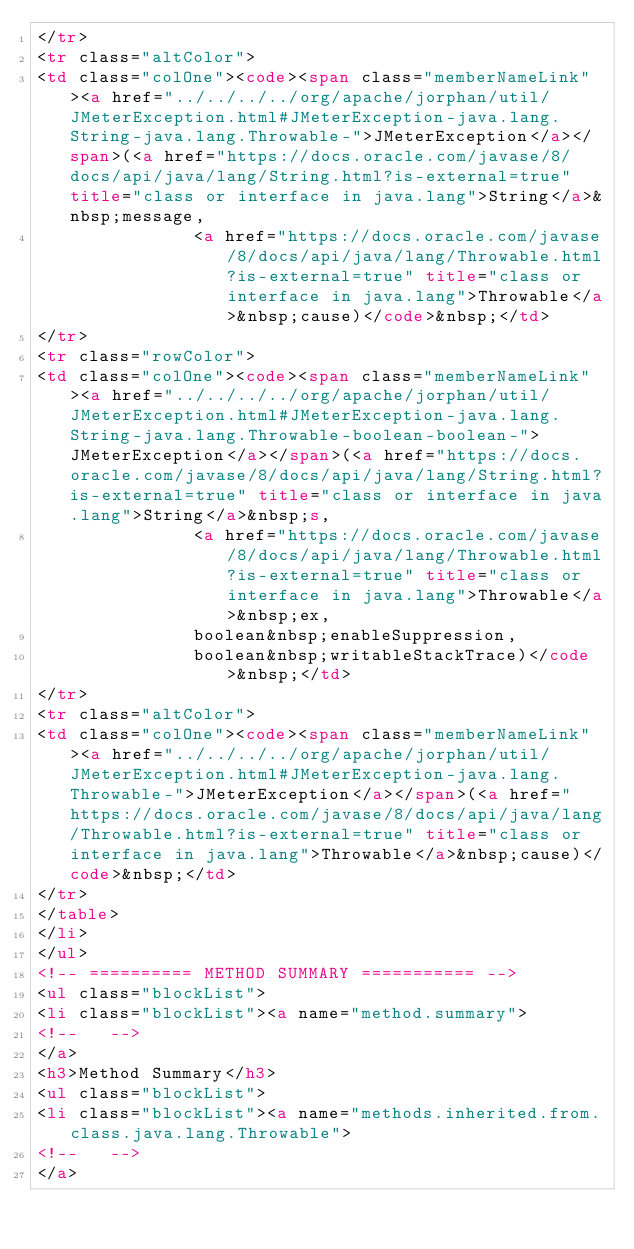Convert code to text. <code><loc_0><loc_0><loc_500><loc_500><_HTML_></tr>
<tr class="altColor">
<td class="colOne"><code><span class="memberNameLink"><a href="../../../../org/apache/jorphan/util/JMeterException.html#JMeterException-java.lang.String-java.lang.Throwable-">JMeterException</a></span>(<a href="https://docs.oracle.com/javase/8/docs/api/java/lang/String.html?is-external=true" title="class or interface in java.lang">String</a>&nbsp;message,
               <a href="https://docs.oracle.com/javase/8/docs/api/java/lang/Throwable.html?is-external=true" title="class or interface in java.lang">Throwable</a>&nbsp;cause)</code>&nbsp;</td>
</tr>
<tr class="rowColor">
<td class="colOne"><code><span class="memberNameLink"><a href="../../../../org/apache/jorphan/util/JMeterException.html#JMeterException-java.lang.String-java.lang.Throwable-boolean-boolean-">JMeterException</a></span>(<a href="https://docs.oracle.com/javase/8/docs/api/java/lang/String.html?is-external=true" title="class or interface in java.lang">String</a>&nbsp;s,
               <a href="https://docs.oracle.com/javase/8/docs/api/java/lang/Throwable.html?is-external=true" title="class or interface in java.lang">Throwable</a>&nbsp;ex,
               boolean&nbsp;enableSuppression,
               boolean&nbsp;writableStackTrace)</code>&nbsp;</td>
</tr>
<tr class="altColor">
<td class="colOne"><code><span class="memberNameLink"><a href="../../../../org/apache/jorphan/util/JMeterException.html#JMeterException-java.lang.Throwable-">JMeterException</a></span>(<a href="https://docs.oracle.com/javase/8/docs/api/java/lang/Throwable.html?is-external=true" title="class or interface in java.lang">Throwable</a>&nbsp;cause)</code>&nbsp;</td>
</tr>
</table>
</li>
</ul>
<!-- ========== METHOD SUMMARY =========== -->
<ul class="blockList">
<li class="blockList"><a name="method.summary">
<!--   -->
</a>
<h3>Method Summary</h3>
<ul class="blockList">
<li class="blockList"><a name="methods.inherited.from.class.java.lang.Throwable">
<!--   -->
</a></code> 